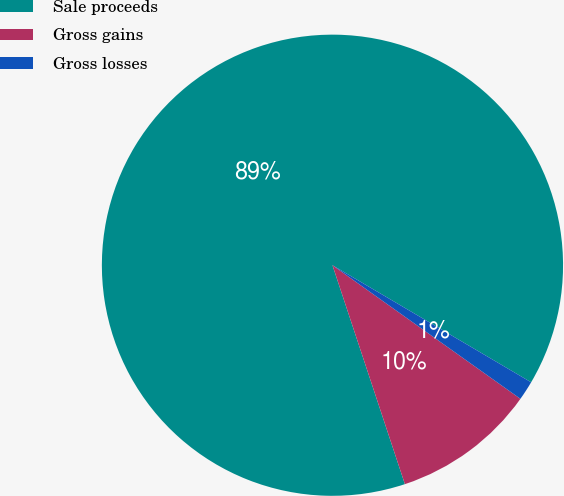Convert chart to OTSL. <chart><loc_0><loc_0><loc_500><loc_500><pie_chart><fcel>Sale proceeds<fcel>Gross gains<fcel>Gross losses<nl><fcel>88.56%<fcel>10.08%<fcel>1.36%<nl></chart> 